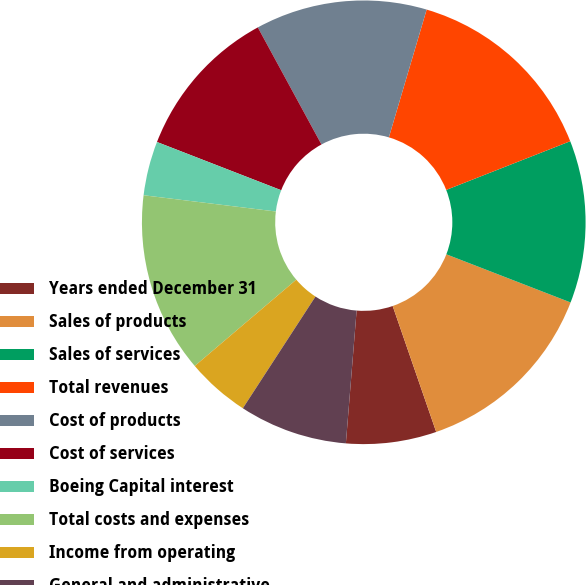Convert chart to OTSL. <chart><loc_0><loc_0><loc_500><loc_500><pie_chart><fcel>Years ended December 31<fcel>Sales of products<fcel>Sales of services<fcel>Total revenues<fcel>Cost of products<fcel>Cost of services<fcel>Boeing Capital interest<fcel>Total costs and expenses<fcel>Income from operating<fcel>General and administrative<nl><fcel>6.58%<fcel>13.82%<fcel>11.84%<fcel>14.47%<fcel>12.5%<fcel>11.18%<fcel>3.95%<fcel>13.16%<fcel>4.61%<fcel>7.89%<nl></chart> 